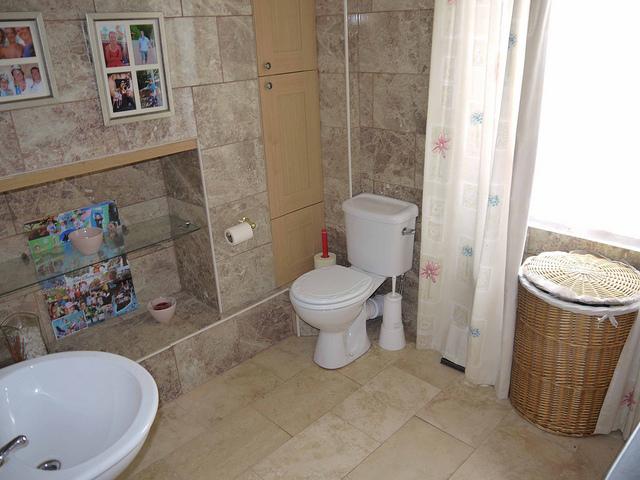What room is the photo?
Give a very brief answer. Bathroom. What color is the toilet brush?
Short answer required. White. Is the hamper open or closed?
Keep it brief. Closed. 